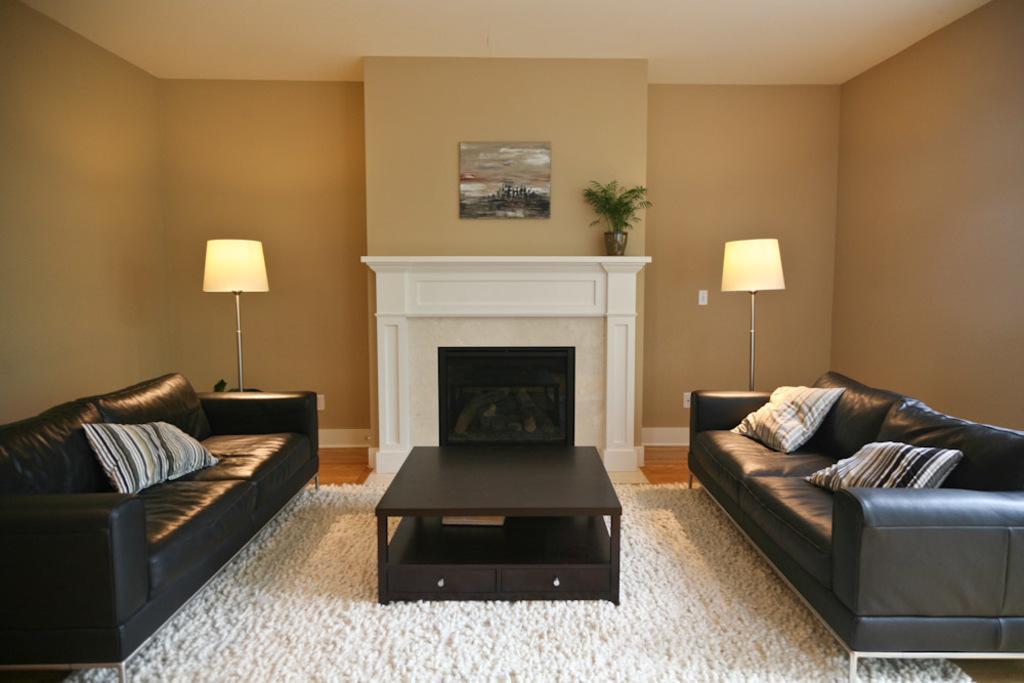In one or two sentences, can you explain what this image depicts? In the image we can see there are two sofas and pillow on it. In front of the sofa there is a table. There are two lamps in the room and a plant pot. There is a picture stick to the wall. there is a carpet which is in white color. 